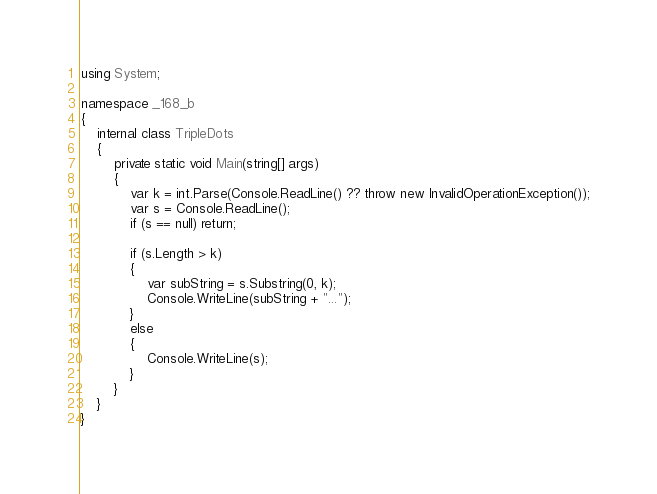<code> <loc_0><loc_0><loc_500><loc_500><_C#_>using System;

namespace _168_b
{
    internal class TripleDots
    {
        private static void Main(string[] args)
        {
            var k = int.Parse(Console.ReadLine() ?? throw new InvalidOperationException());
            var s = Console.ReadLine();
            if (s == null) return;

            if (s.Length > k)
            {
                var subString = s.Substring(0, k);
                Console.WriteLine(subString + "...");
            }
            else
            {
                Console.WriteLine(s);
            }
        }
    }
}</code> 